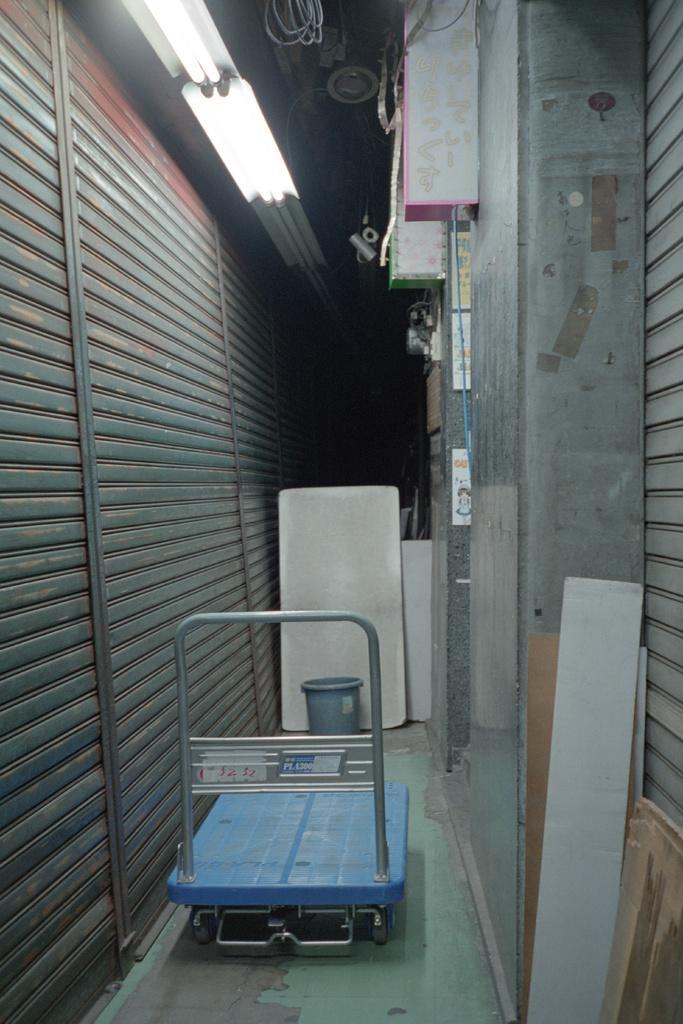How would you summarize this image in a sentence or two? In this picture I can see a luggage trolley and a small dustbin and few wooden planks and I can see lights and I can see metal shutters on both sides. 